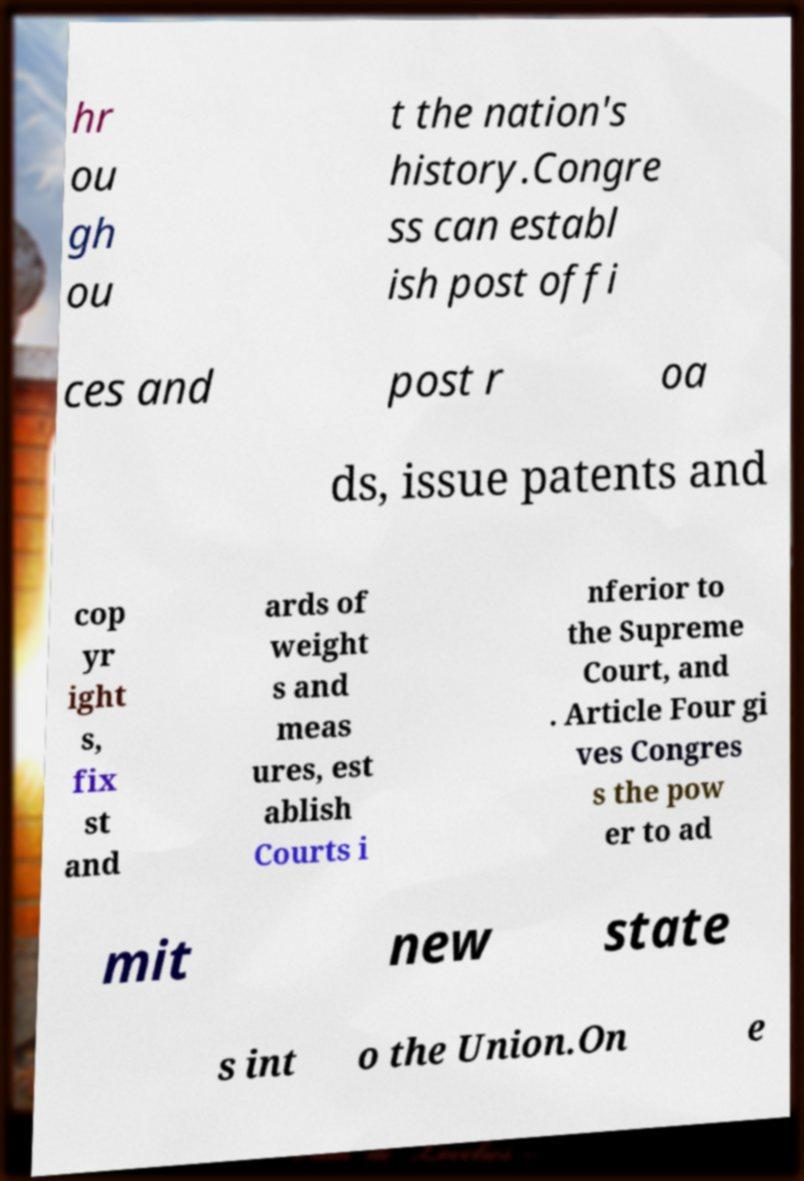Please identify and transcribe the text found in this image. hr ou gh ou t the nation's history.Congre ss can establ ish post offi ces and post r oa ds, issue patents and cop yr ight s, fix st and ards of weight s and meas ures, est ablish Courts i nferior to the Supreme Court, and . Article Four gi ves Congres s the pow er to ad mit new state s int o the Union.On e 